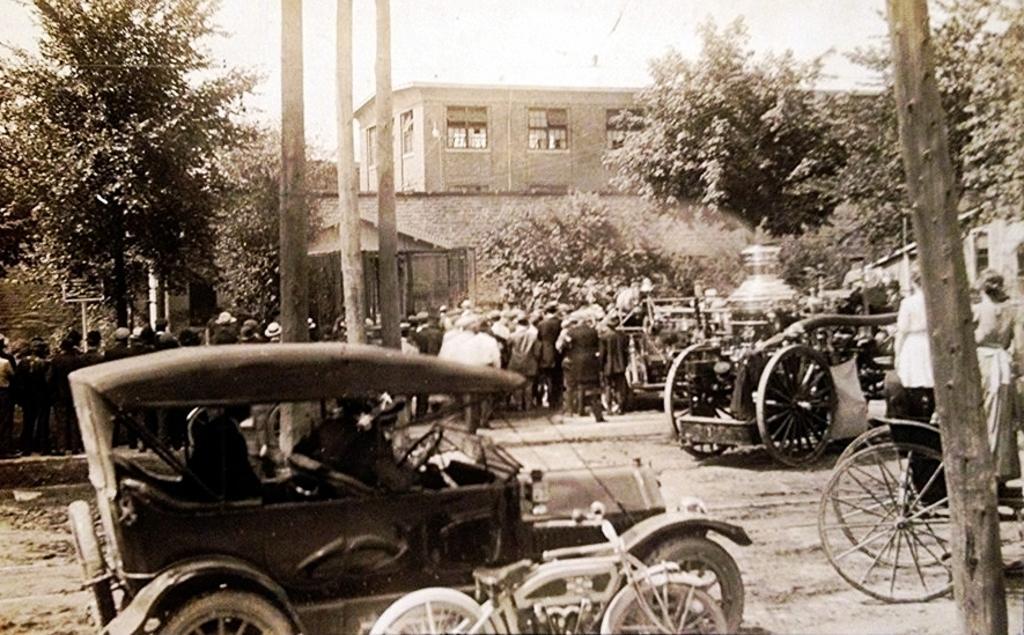Describe this image in one or two sentences. This is a black and white picture. In this picture, we see a jeep, bicycles, cart and a vehicle. In the middle, we see the poles and we see the people are standing. On the right side, we see a wooden pole, a wall and the trees. In the background, we see the trees and a building. At the top, we see the sky. 